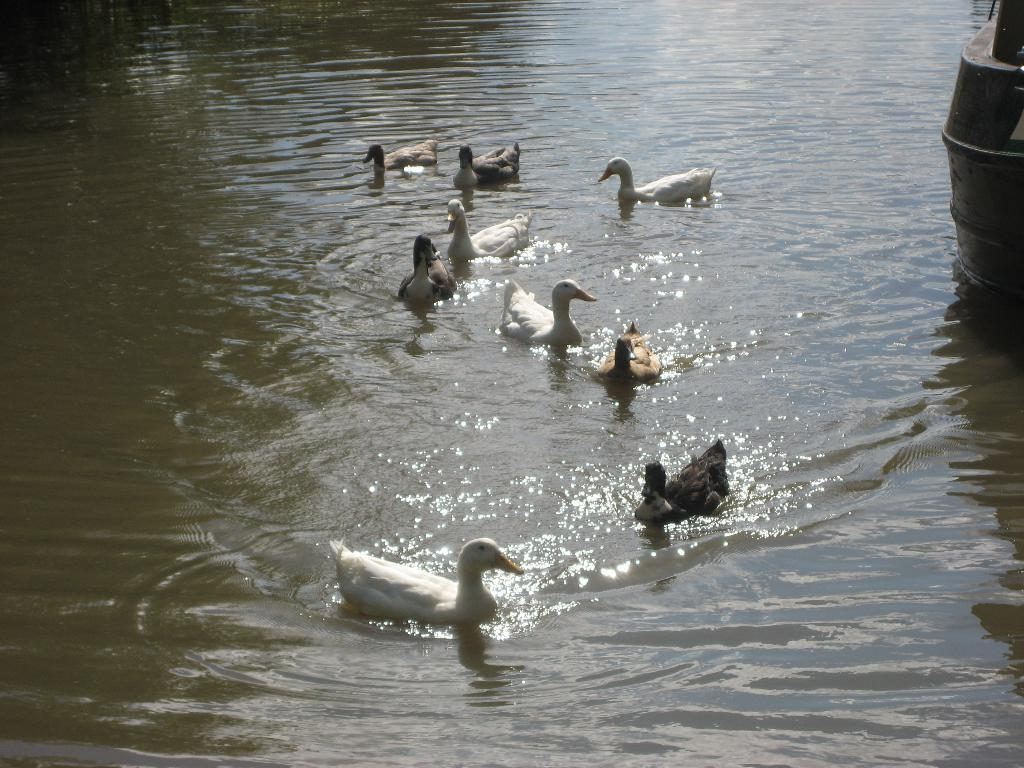What type of animals can be seen in the image? There are ducks in the water. Can you describe the object on the right side of the image? Unfortunately, the facts provided do not give any information about the object on the right side of the image. How does the duck's wealth affect their friendship with the other ducks in the image? There is no information about the ducks' wealth or friendships in the image, so it is not possible to answer this question. 